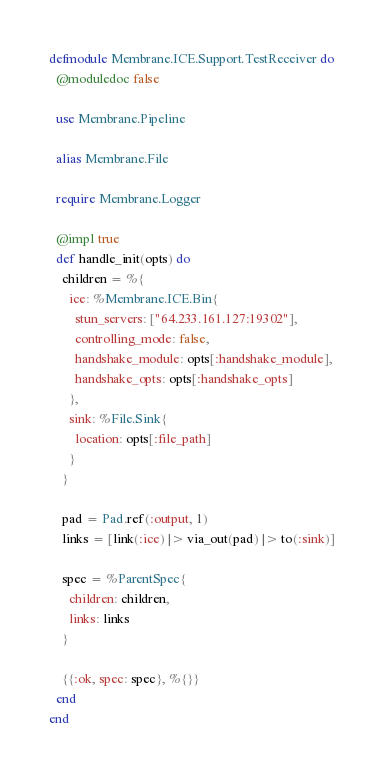<code> <loc_0><loc_0><loc_500><loc_500><_Elixir_>defmodule Membrane.ICE.Support.TestReceiver do
  @moduledoc false

  use Membrane.Pipeline

  alias Membrane.File

  require Membrane.Logger

  @impl true
  def handle_init(opts) do
    children = %{
      ice: %Membrane.ICE.Bin{
        stun_servers: ["64.233.161.127:19302"],
        controlling_mode: false,
        handshake_module: opts[:handshake_module],
        handshake_opts: opts[:handshake_opts]
      },
      sink: %File.Sink{
        location: opts[:file_path]
      }
    }

    pad = Pad.ref(:output, 1)
    links = [link(:ice) |> via_out(pad) |> to(:sink)]

    spec = %ParentSpec{
      children: children,
      links: links
    }

    {{:ok, spec: spec}, %{}}
  end
end
</code> 